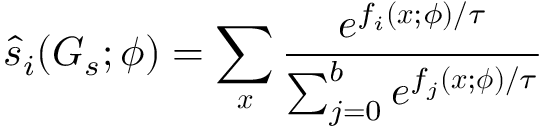Convert formula to latex. <formula><loc_0><loc_0><loc_500><loc_500>\hat { s } _ { i } ( G _ { s } ; \phi ) = \sum _ { x } \frac { e ^ { f _ { i } ( x ; \phi ) / \tau } } { \sum _ { j = 0 } ^ { b } e ^ { f _ { j } ( x ; \phi ) / \tau } }</formula> 